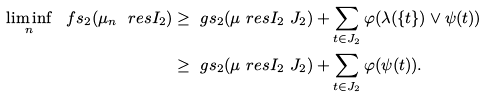<formula> <loc_0><loc_0><loc_500><loc_500>\liminf _ { n } \ f s _ { 2 } ( \mu _ { n } \ r e s I _ { 2 } ) & \geq \ g s _ { 2 } ( \mu \ r e s { I _ { 2 } \ J _ { 2 } } ) + \sum _ { t \in J _ { 2 } } \varphi ( \lambda ( \{ t \} ) \lor \psi ( t ) ) \\ & \geq \ g s _ { 2 } ( \mu \ r e s { I _ { 2 } \ J _ { 2 } } ) + \sum _ { t \in J _ { 2 } } \varphi ( \psi ( t ) ) .</formula> 